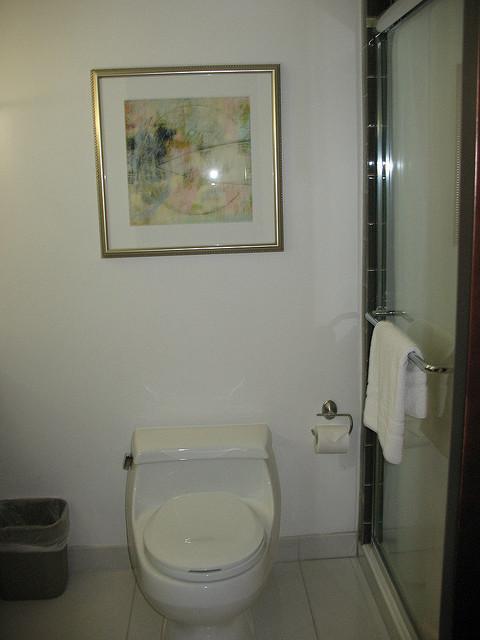How many places are reflecting the flash?
Give a very brief answer. 2. How many folded towels do count?
Give a very brief answer. 1. How many towels are there?
Give a very brief answer. 1. How many mirrors are shown?
Give a very brief answer. 0. How many hand towels are in this bathroom?
Give a very brief answer. 1. How many rolls of toilet paper are there?
Give a very brief answer. 1. How many towels are pictured?
Give a very brief answer. 1. How many towels are in the room?
Give a very brief answer. 1. 